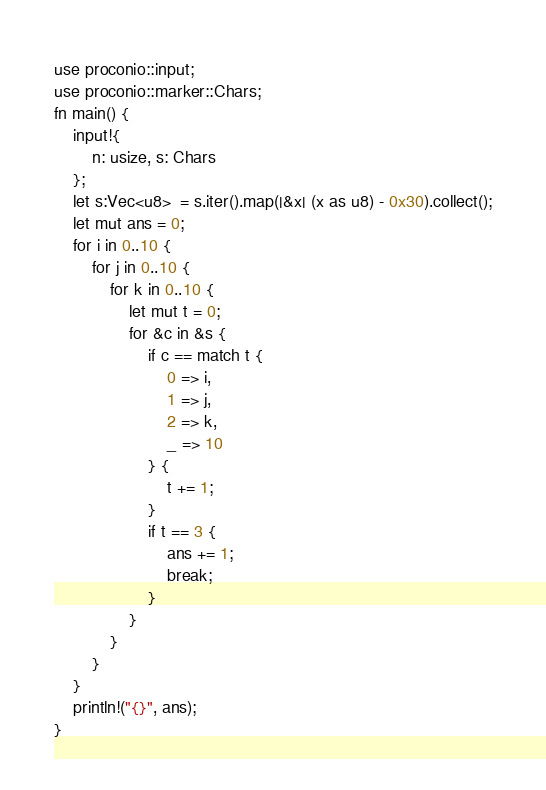Convert code to text. <code><loc_0><loc_0><loc_500><loc_500><_Rust_>use proconio::input;
use proconio::marker::Chars;
fn main() {
    input!{
        n: usize, s: Chars
    };
    let s:Vec<u8>  = s.iter().map(|&x| (x as u8) - 0x30).collect();
    let mut ans = 0;
    for i in 0..10 {
        for j in 0..10 {
            for k in 0..10 {
                let mut t = 0;
                for &c in &s {
                    if c == match t {
                        0 => i,
                        1 => j,
                        2 => k,
                        _ => 10
                    } {
                        t += 1;
                    }
                    if t == 3 {
                        ans += 1;
                        break;
                    }
                }
            }
        }
    }
    println!("{}", ans);
}</code> 